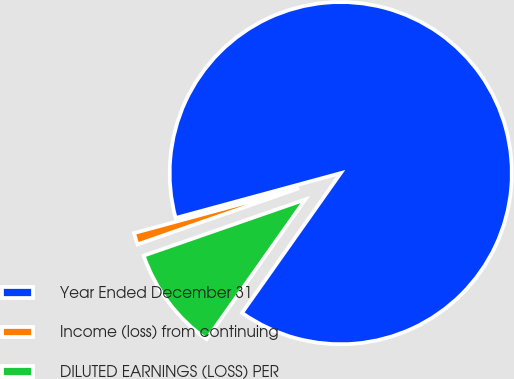Convert chart. <chart><loc_0><loc_0><loc_500><loc_500><pie_chart><fcel>Year Ended December 31<fcel>Income (loss) from continuing<fcel>DILUTED EARNINGS (LOSS) PER<nl><fcel>89.0%<fcel>1.1%<fcel>9.89%<nl></chart> 